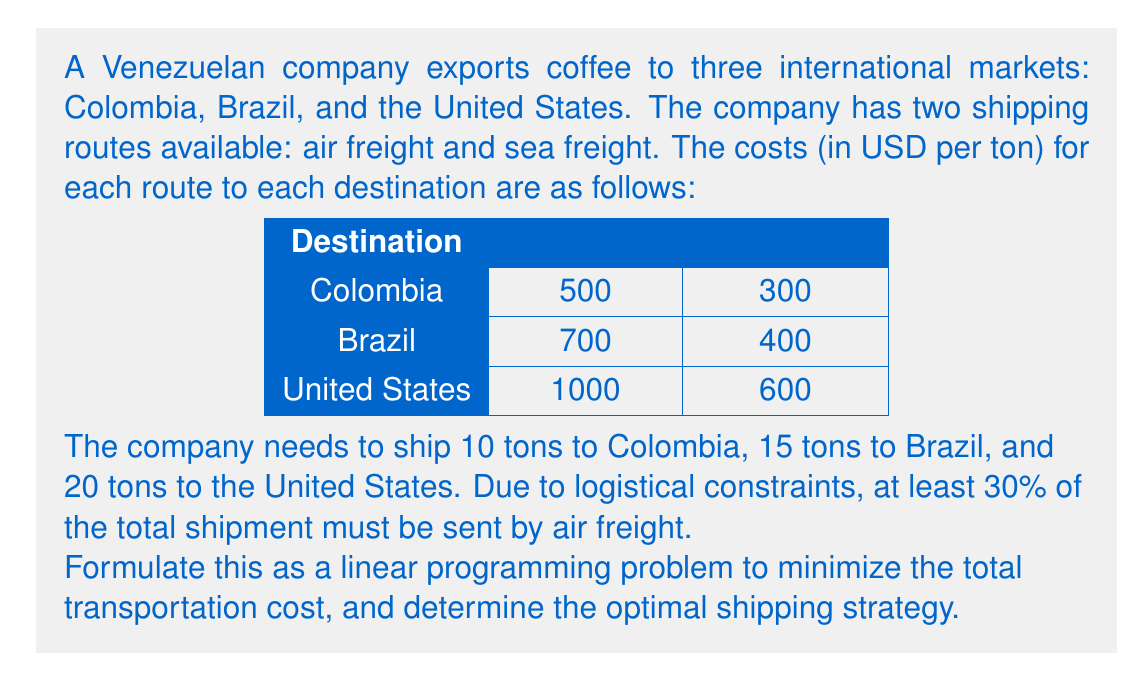What is the answer to this math problem? Let's approach this step-by-step:

1) Define variables:
   Let $x_{ij}$ be the amount (in tons) shipped to destination $i$ via method $j$
   where $i \in \{\text{C (Colombia), B (Brazil), U (US)}\}$ and $j \in \{\text{A (Air), S (Sea)}\}$

2) Objective function:
   Minimize total cost:
   $$\text{Min } Z = 500x_{CA} + 300x_{CS} + 700x_{BA} + 400x_{BS} + 1000x_{UA} + 600x_{US}$$

3) Constraints:
   a) Demand constraints:
      Colombia: $x_{CA} + x_{CS} = 10$
      Brazil: $x_{BA} + x_{BS} = 15$
      US: $x_{UA} + x_{US} = 20$

   b) Air freight constraint (at least 30% of total 45 tons):
      $x_{CA} + x_{BA} + x_{UA} \geq 0.3(45) = 13.5$

   c) Non-negativity:
      $x_{CA}, x_{CS}, x_{BA}, x_{BS}, x_{UA}, x_{US} \geq 0$

4) Solving:
   This problem can be solved using the simplex method or linear programming software. The optimal solution is:

   $x_{CA} = 3, x_{CS} = 7, x_{BA} = 4.5, x_{BS} = 10.5, x_{UA} = 6, x_{US} = 14$

5) Verification:
   - Total air freight: $3 + 4.5 + 6 = 13.5$ tons (30% of total)
   - Demands met: Colombia (3 + 7 = 10), Brazil (4.5 + 10.5 = 15), US (6 + 14 = 20)

6) Total cost:
   $Z = 500(3) + 300(7) + 700(4.5) + 400(10.5) + 1000(6) + 600(14) = 24,150$ USD
Answer: The optimal shipping strategy is:
- To Colombia: 3 tons by air, 7 tons by sea
- To Brazil: 4.5 tons by air, 10.5 tons by sea
- To US: 6 tons by air, 14 tons by sea

The minimum total transportation cost is $24,150 USD. 